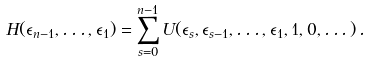Convert formula to latex. <formula><loc_0><loc_0><loc_500><loc_500>H ( \epsilon _ { n - 1 } , \dots , \epsilon _ { 1 } ) = \sum _ { s = 0 } ^ { n - 1 } U ( \epsilon _ { s } , \epsilon _ { s - 1 } , \dots , \epsilon _ { 1 } , 1 , 0 , \dots ) \, .</formula> 